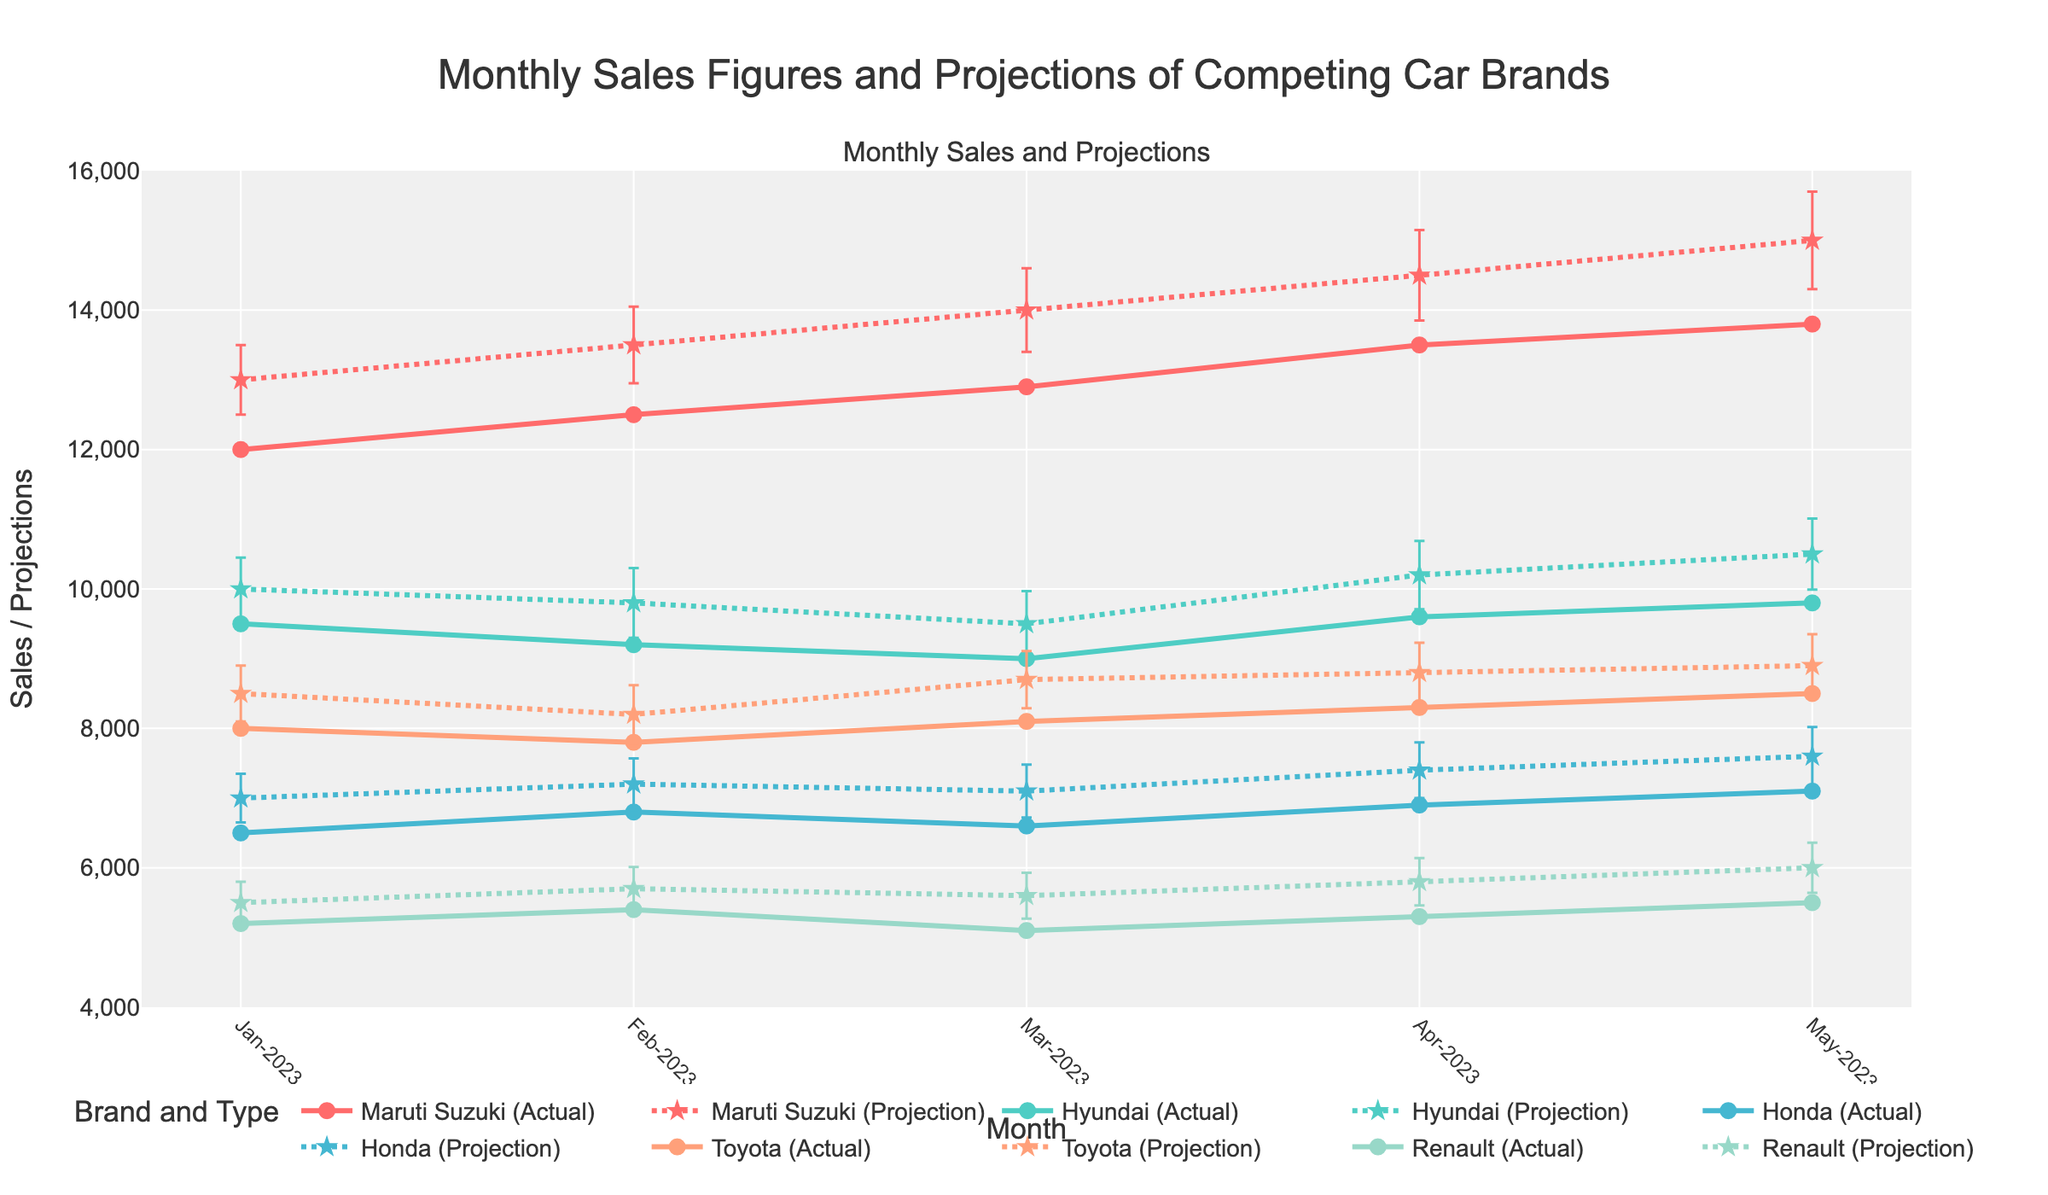What is the highest actual sales figure for Maruti Suzuki? To find the highest actual sales figure for Maruti Suzuki, look at the 'Sales' data points for Maruti Suzuki across all months. The highest is 13800 in May-2023.
Answer: 13800 In which month did Renault have the lowest actual sales? Find the minimum 'Sales' value for Renault and identify the corresponding month. The lowest sales for Renault is 5100 in Mar-2023.
Answer: Mar-2023 What are the average actual sales of Hyundai from Jan-2023 to May-2023? Sum the actual sales of Hyundai from Jan-2023 to May-2023 (9500 + 9200 + 9000 + 9600 + 9800) and divide by the number of months, which is 5. [(9500 + 9200 + 9000 + 9600 + 9800) / 5 = 9420]
Answer: 9420 Which brand had a higher actual sales figure in Feb-2023, Maruti Suzuki or Toyota? Compare Maruti Suzuki's actual sales (12500) with Toyota's actual sales (7800) in Feb-2023. Maruti Suzuki had higher sales.
Answer: Maruti Suzuki What is the projected sales figure for Honda in Apr-2023, and what is the range of uncertainty? Look at the 'Projection' for Honda in Apr-2023 (7400) and 'Uncertainty' (400). The range of uncertainty is from (7400 - 400) to (7400 + 400), i.e., 7000 to 7800.
Answer: 7400, range 7000 to 7800 Does the actual sales figure for Maruti Suzuki consistently increase from Jan-2023 to May-2023? Check the trend of Maruti Suzuki's actual sales from Jan-2023 to May-2023 (12000, 12500, 12900, 13500, 13800). The sales figures show a consistent month-over-month increase.
Answer: Yes In which month did Hyundai have the smallest difference between actual sales and projected sales? Calculate the difference between actual sales and projected sales for Hyundai for each month and find the smallest difference. The differences are: Jan-2023 (500), Feb-2023 (600), Mar-2023 (500), Apr-2023 (600), May-2023 (700). The smallest difference is in Jan-2023.
Answer: Jan-2023 By how much did Toyota's actual sales increase from Jan-2023 to Apr-2023? Subtract Toyota's actual sales in Jan-2023 (8000) from its actual sales in Apr-2023 (8300). 8300 - 8000 = 300.
Answer: 300 What is the uncertainty range for Maruti Suzuki's projected sales in May-2023? Identify Maruti Suzuki’s projected sales in May-2023 (15000) and its uncertainty (700). The range is from (15000 - 700) to (15000 + 700), i.e., 14300 to 15700.
Answer: 14300 to 15700 